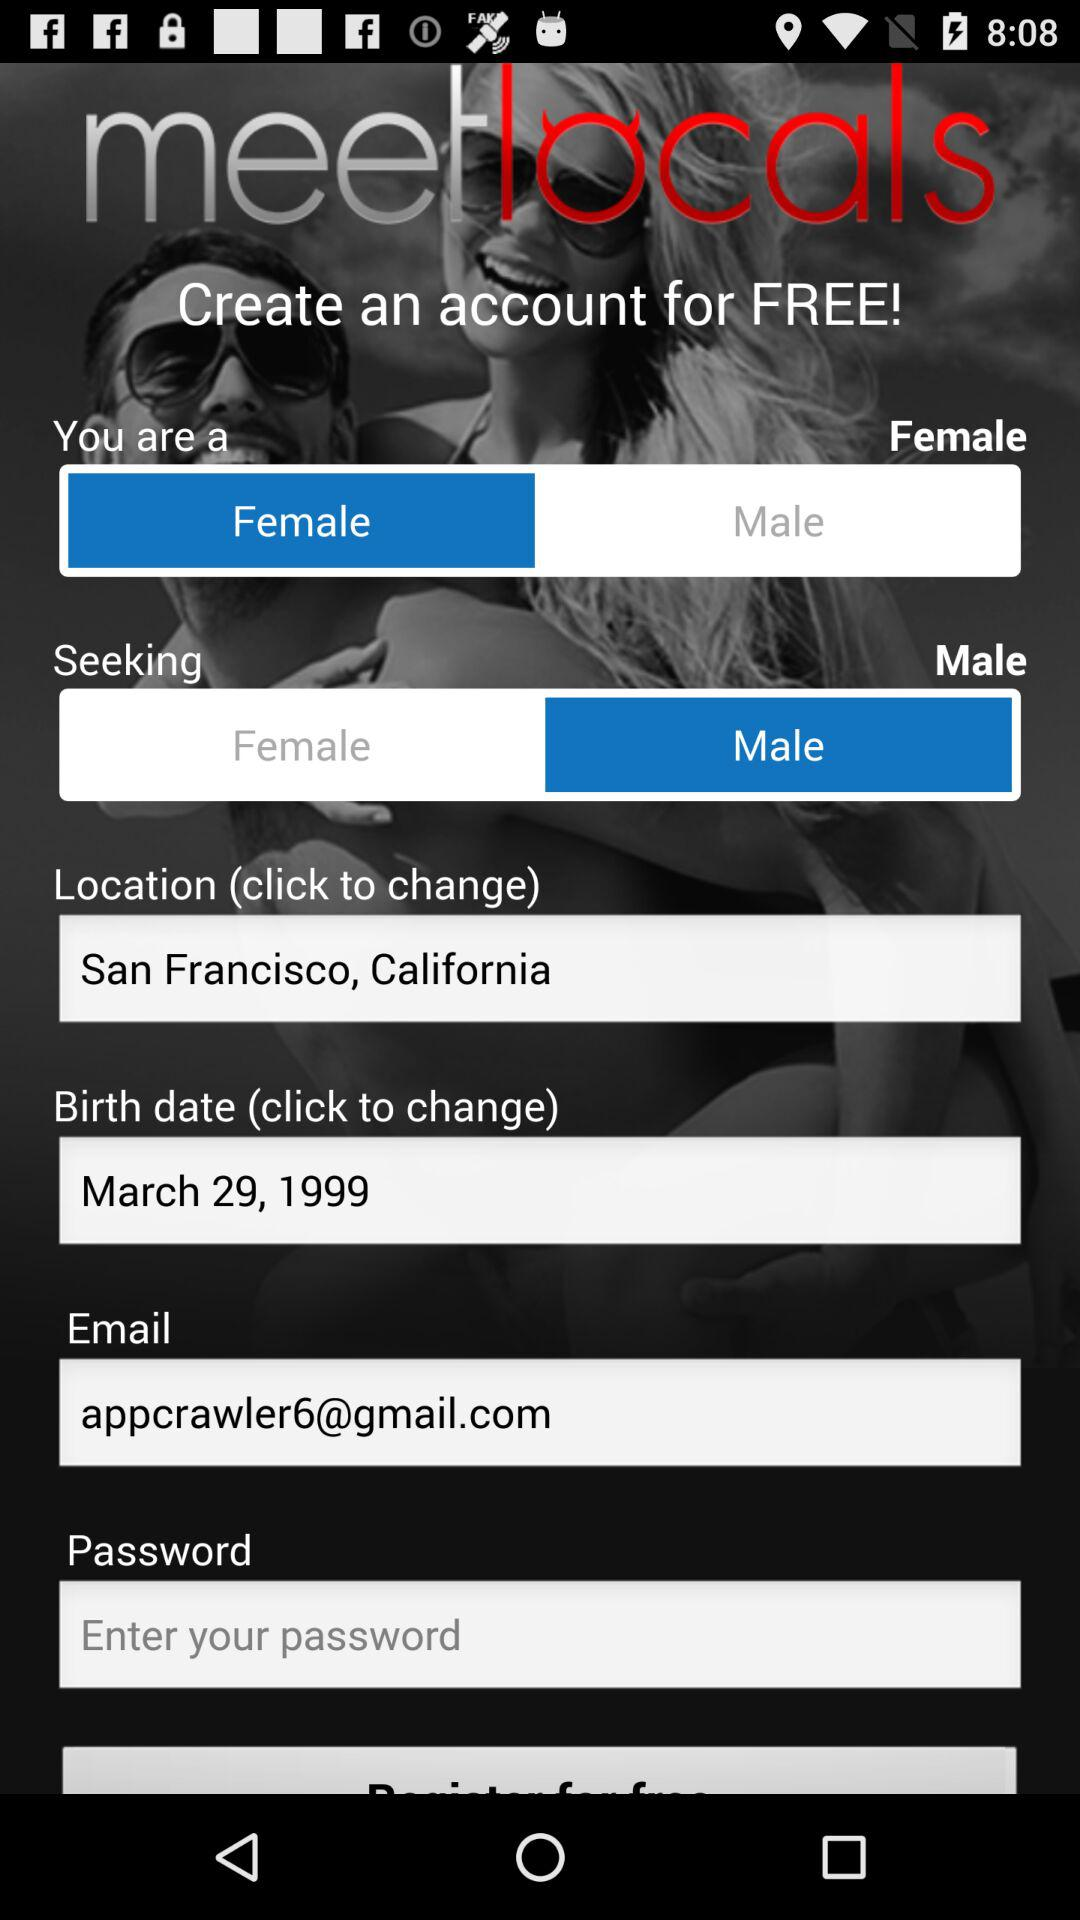What is the location? The location is San Francisco, California. 